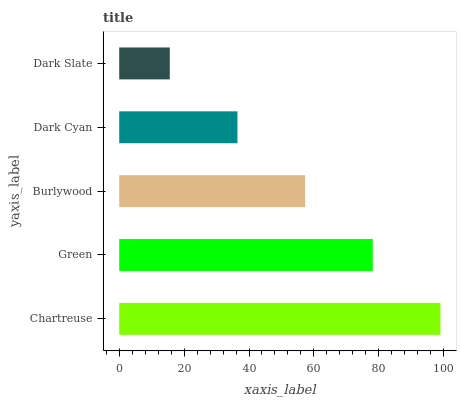Is Dark Slate the minimum?
Answer yes or no. Yes. Is Chartreuse the maximum?
Answer yes or no. Yes. Is Green the minimum?
Answer yes or no. No. Is Green the maximum?
Answer yes or no. No. Is Chartreuse greater than Green?
Answer yes or no. Yes. Is Green less than Chartreuse?
Answer yes or no. Yes. Is Green greater than Chartreuse?
Answer yes or no. No. Is Chartreuse less than Green?
Answer yes or no. No. Is Burlywood the high median?
Answer yes or no. Yes. Is Burlywood the low median?
Answer yes or no. Yes. Is Dark Cyan the high median?
Answer yes or no. No. Is Green the low median?
Answer yes or no. No. 